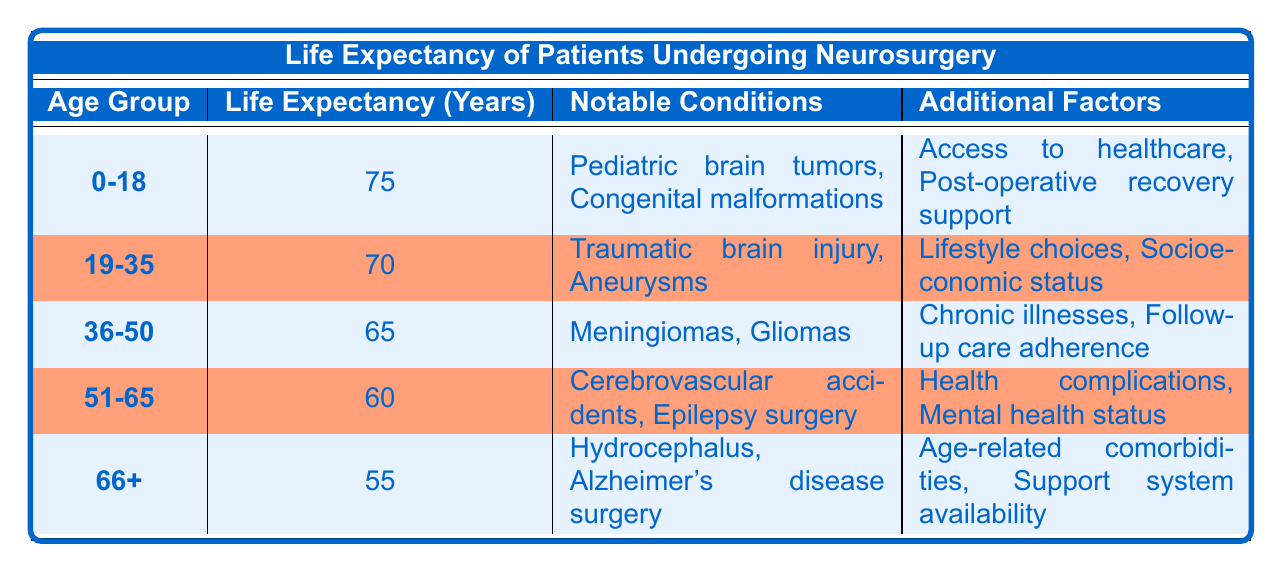What is the life expectancy for patients aged 51-65 undergoing neurosurgery? The table shows that for the age group 51-65, the life expectancy is listed as 60 years.
Answer: 60 Which age group has the highest conditional life expectancy? Referring to the table, the age group 0-18 has a conditional life expectancy of 75 years, which is the highest compared to the other age groups.
Answer: 0-18 Are cerebrovascular accidents a notable condition for patients aged 36-50? Yes, the table indicates that cerebrovascular accidents are indeed listed as a notable condition for the age group 51-65, but not for 36-50, which has meningiomas and gliomas as notable conditions.
Answer: No What is the difference in life expectancy between the 19-35 and 66+ age groups? From the table, the life expectancy for the 19-35 age group is 70 years, and for the 66+ age group, it is 55 years. The difference is calculated as 70 - 55 = 15 years.
Answer: 15 What is the average life expectancy of patients undergoing neurosurgery across all age groups? To find the average, we first sum the life expectancy of all age groups: 75 + 70 + 65 + 60 + 55 = 325 years. Then divide this total by the number of age groups (5), resulting in an average of 325/5 = 65 years.
Answer: 65 Do patients aged 36-50 and 51-65 share any notable conditions? Looking at the table, the notable conditions for patients aged 36-50 are meningiomas and gliomas, while for 51-65, they are cerebrovascular accidents and epilepsy surgery. There are no shared notable conditions between these two age groups.
Answer: No What trends can be observed in the life expectancy as age increases? Analyzing the data, we see that life expectancy decreases as the age group increases: starting from 75 years (0-18) to 55 years (66+). This indicates that, generally, older patients have a lower conditional life expectancy following neurosurgery.
Answer: Decreasing trend What are the additional factors affecting life expectancy for the age group 66+? The table lists two additional factors for the age group 66+, which are age-related comorbidities and support system availability. These factors could influence both the surgical outcome and recovery process, affecting life expectancy.
Answer: Age-related comorbidities, support system availability How many notable conditions are listed for the 19-35 age group? The table specifies that there are two notable conditions for this age group: traumatic brain injury and aneurysms.
Answer: 2 